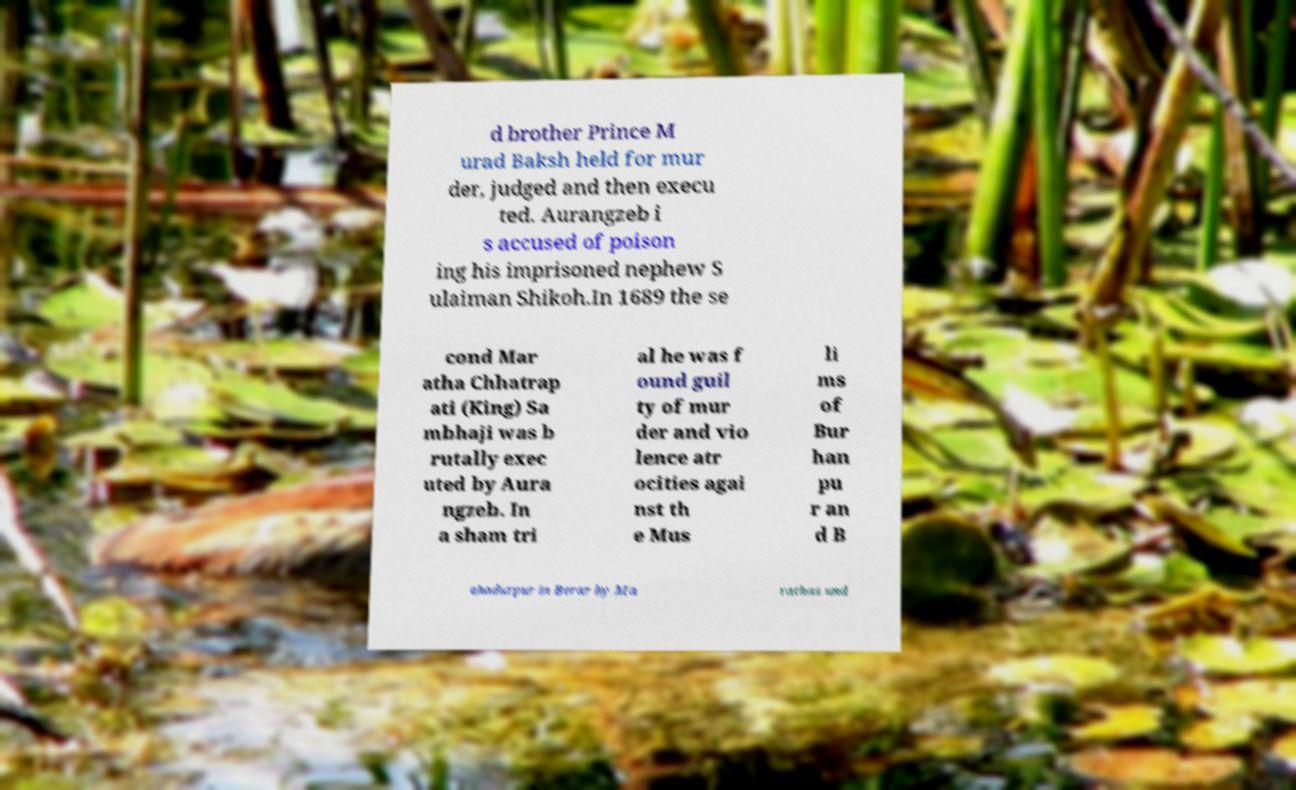Please identify and transcribe the text found in this image. d brother Prince M urad Baksh held for mur der, judged and then execu ted. Aurangzeb i s accused of poison ing his imprisoned nephew S ulaiman Shikoh.In 1689 the se cond Mar atha Chhatrap ati (King) Sa mbhaji was b rutally exec uted by Aura ngzeb. In a sham tri al he was f ound guil ty of mur der and vio lence atr ocities agai nst th e Mus li ms of Bur han pu r an d B ahadurpur in Berar by Ma rathas und 